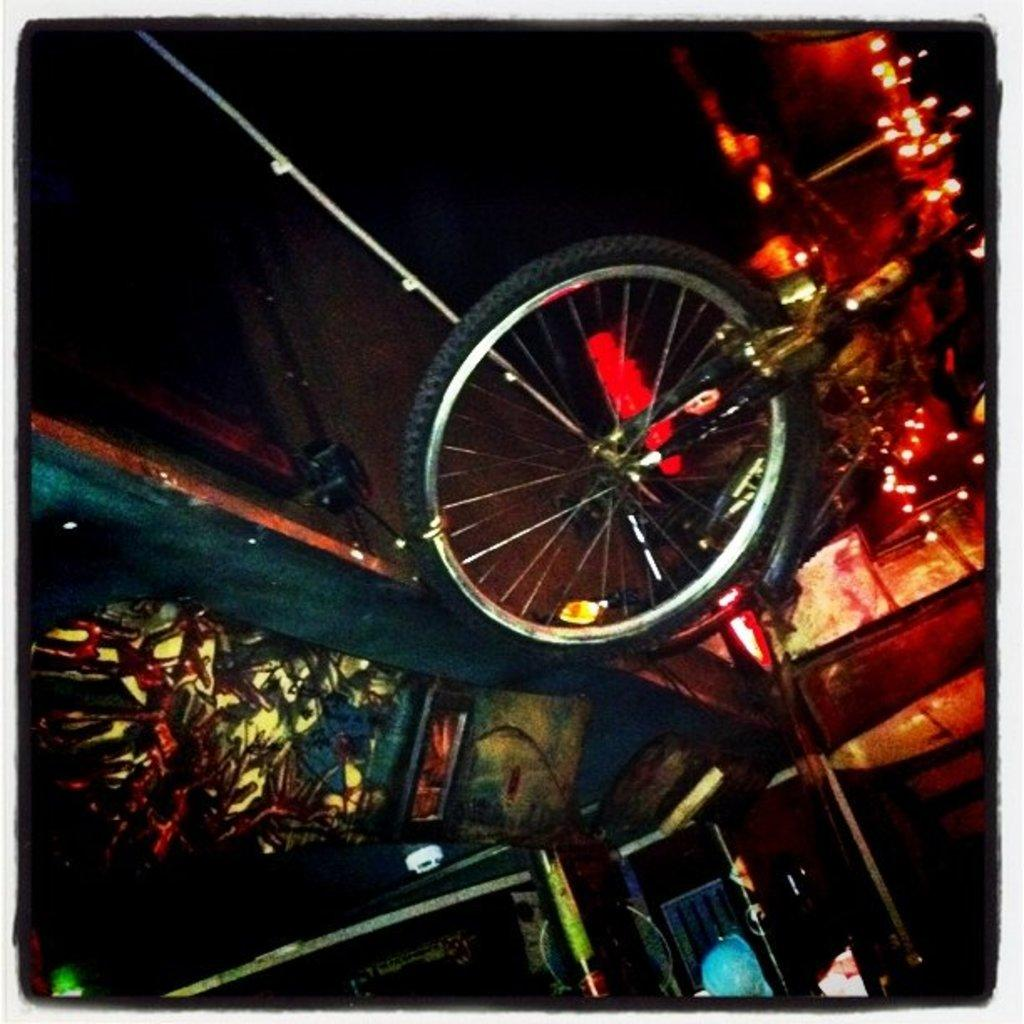What is the main object in the image? There is a bicycle in the image. What else can be seen in the image besides the bicycle? There are lights in the image. Can you describe any other objects in the image? There are some other unspecified objects in the image. How many legs does the pan have in the image? There is no pan present in the image, so it is not possible to determine the number of legs it might have. 